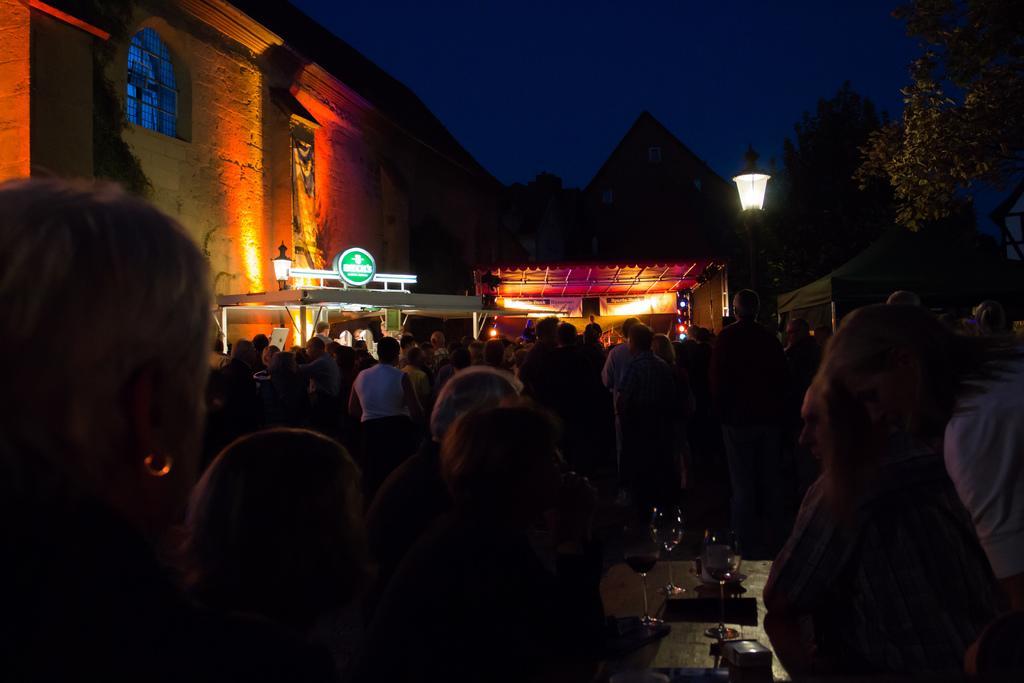Can you describe this image briefly? In this picture we can see the group of persons standing near to the table. On the table we can see wine glasses, box and book. In the back we can see buildings and board. Here we can see street light near to the trees. At the top there is a sky. 